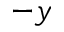<formula> <loc_0><loc_0><loc_500><loc_500>- y</formula> 